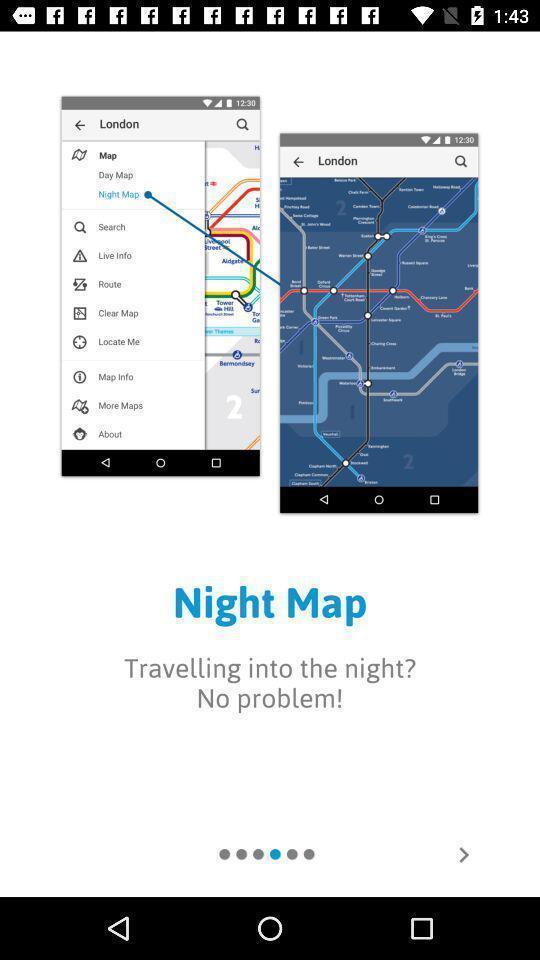Tell me about the visual elements in this screen capture. Welcome page of a mapping app. 